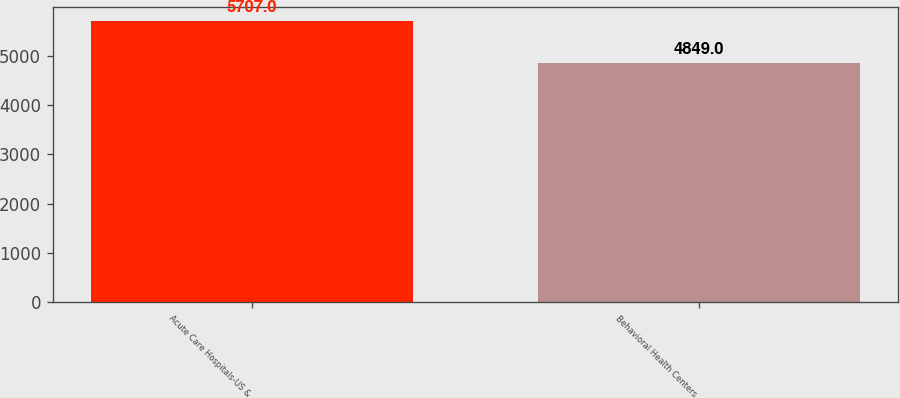Convert chart. <chart><loc_0><loc_0><loc_500><loc_500><bar_chart><fcel>Acute Care Hospitals-US &<fcel>Behavioral Health Centers<nl><fcel>5707<fcel>4849<nl></chart> 